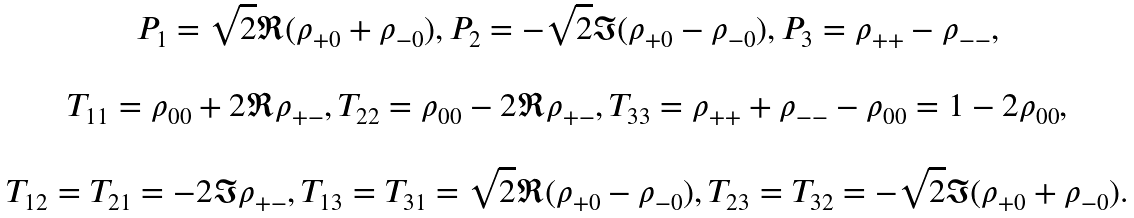Convert formula to latex. <formula><loc_0><loc_0><loc_500><loc_500>\begin{array} { c } P _ { 1 } = \sqrt { 2 } \Re ( \rho _ { + 0 } + \rho _ { - 0 } ) , P _ { 2 } = - \sqrt { 2 } \Im ( \rho _ { + 0 } - \rho _ { - 0 } ) , P _ { 3 } = \rho _ { + + } - \rho _ { - - } , \\ \\ T _ { 1 1 } = \rho _ { 0 0 } + 2 \Re \rho _ { + - } , T _ { 2 2 } = \rho _ { 0 0 } - 2 \Re \rho _ { + - } , T _ { 3 3 } = \rho _ { + + } + \rho _ { - - } - \rho _ { 0 0 } = 1 - 2 \rho _ { 0 0 } , \\ \\ T _ { 1 2 } = T _ { 2 1 } = - 2 \Im \rho _ { + - } , T _ { 1 3 } = T _ { 3 1 } = \sqrt { 2 } \Re ( \rho _ { + 0 } - \rho _ { - 0 } ) , T _ { 2 3 } = T _ { 3 2 } = - \sqrt { 2 } \Im ( \rho _ { + 0 } + \rho _ { - 0 } ) . \end{array}</formula> 